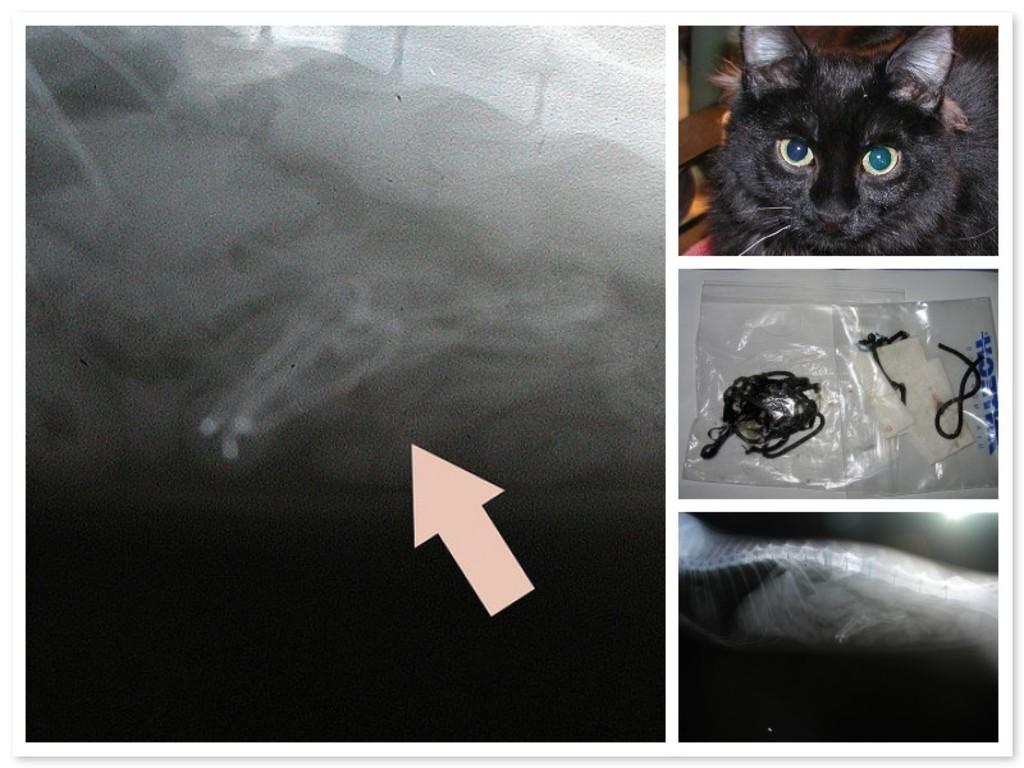How would you summarize this image in a sentence or two? It is the photo collage, on the right side there is a black color cat. At the down side it is the x-ray. 